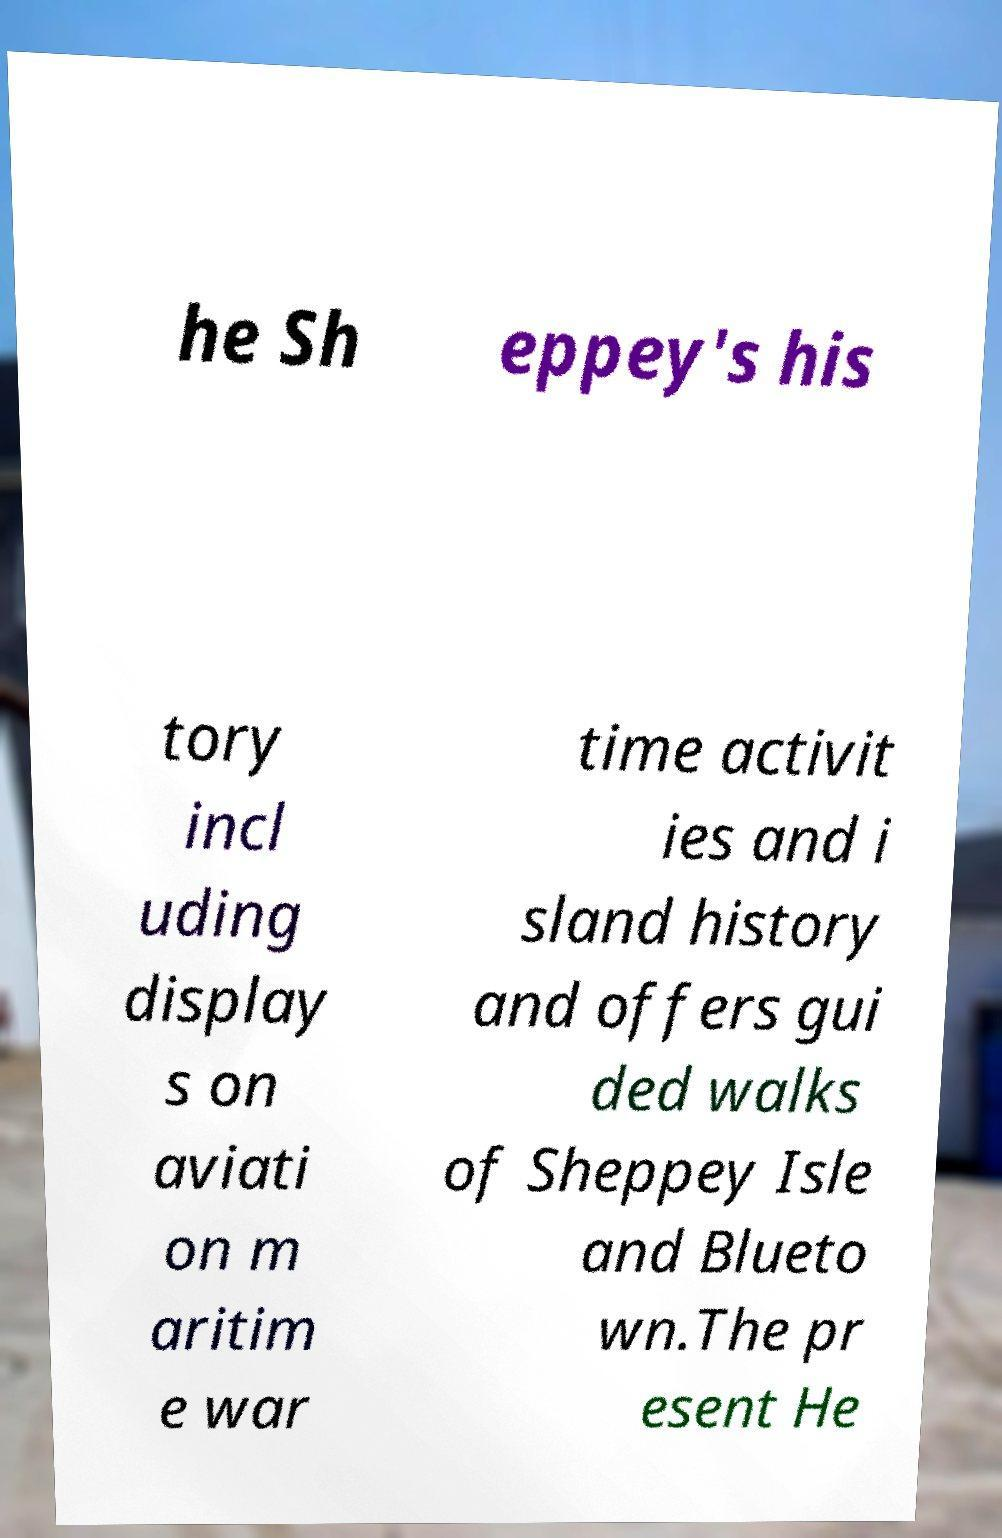I need the written content from this picture converted into text. Can you do that? he Sh eppey's his tory incl uding display s on aviati on m aritim e war time activit ies and i sland history and offers gui ded walks of Sheppey Isle and Blueto wn.The pr esent He 